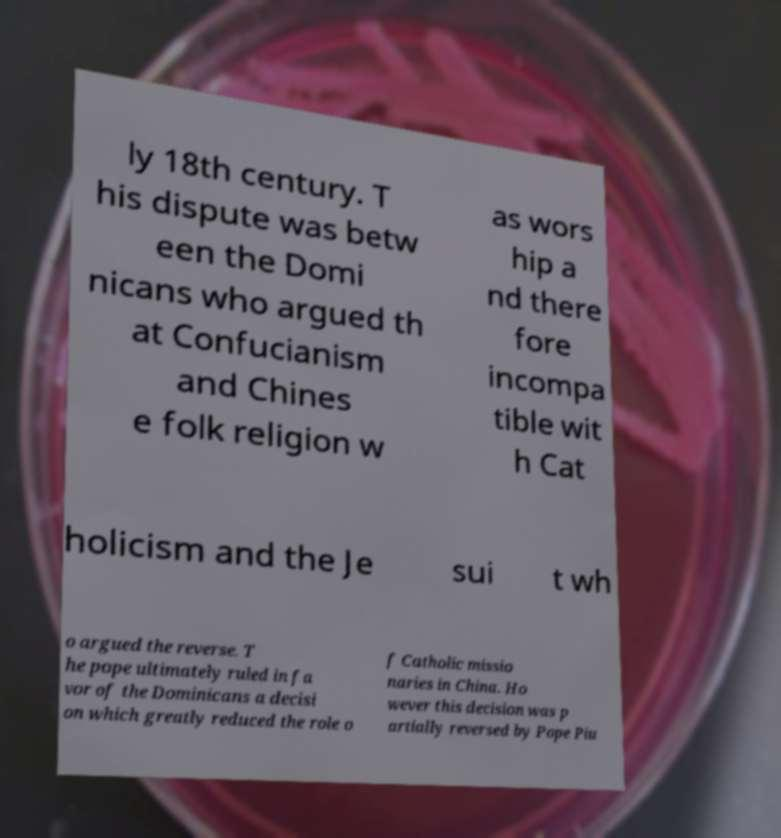Could you extract and type out the text from this image? ly 18th century. T his dispute was betw een the Domi nicans who argued th at Confucianism and Chines e folk religion w as wors hip a nd there fore incompa tible wit h Cat holicism and the Je sui t wh o argued the reverse. T he pope ultimately ruled in fa vor of the Dominicans a decisi on which greatly reduced the role o f Catholic missio naries in China. Ho wever this decision was p artially reversed by Pope Piu 